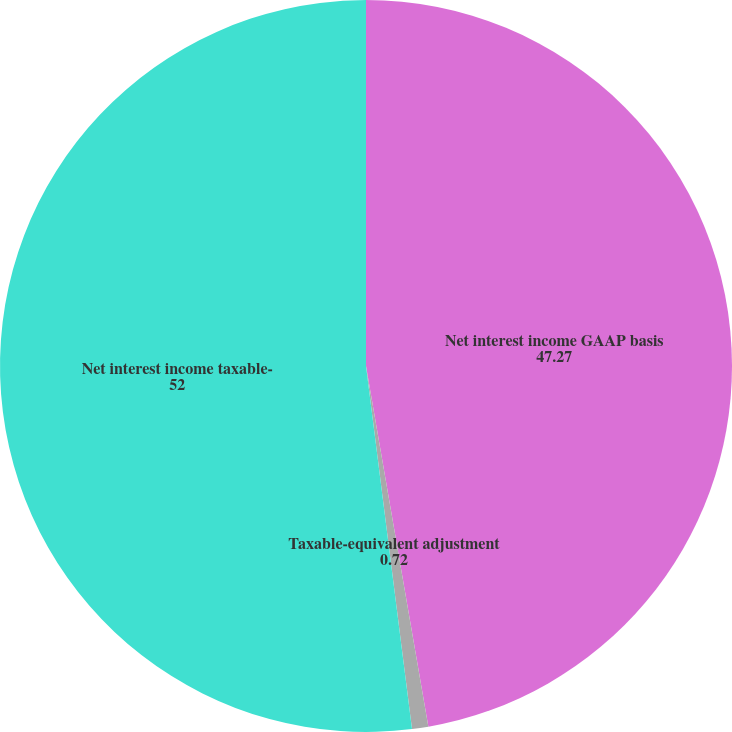Convert chart to OTSL. <chart><loc_0><loc_0><loc_500><loc_500><pie_chart><fcel>Net interest income GAAP basis<fcel>Taxable-equivalent adjustment<fcel>Net interest income taxable-<nl><fcel>47.27%<fcel>0.72%<fcel>52.0%<nl></chart> 